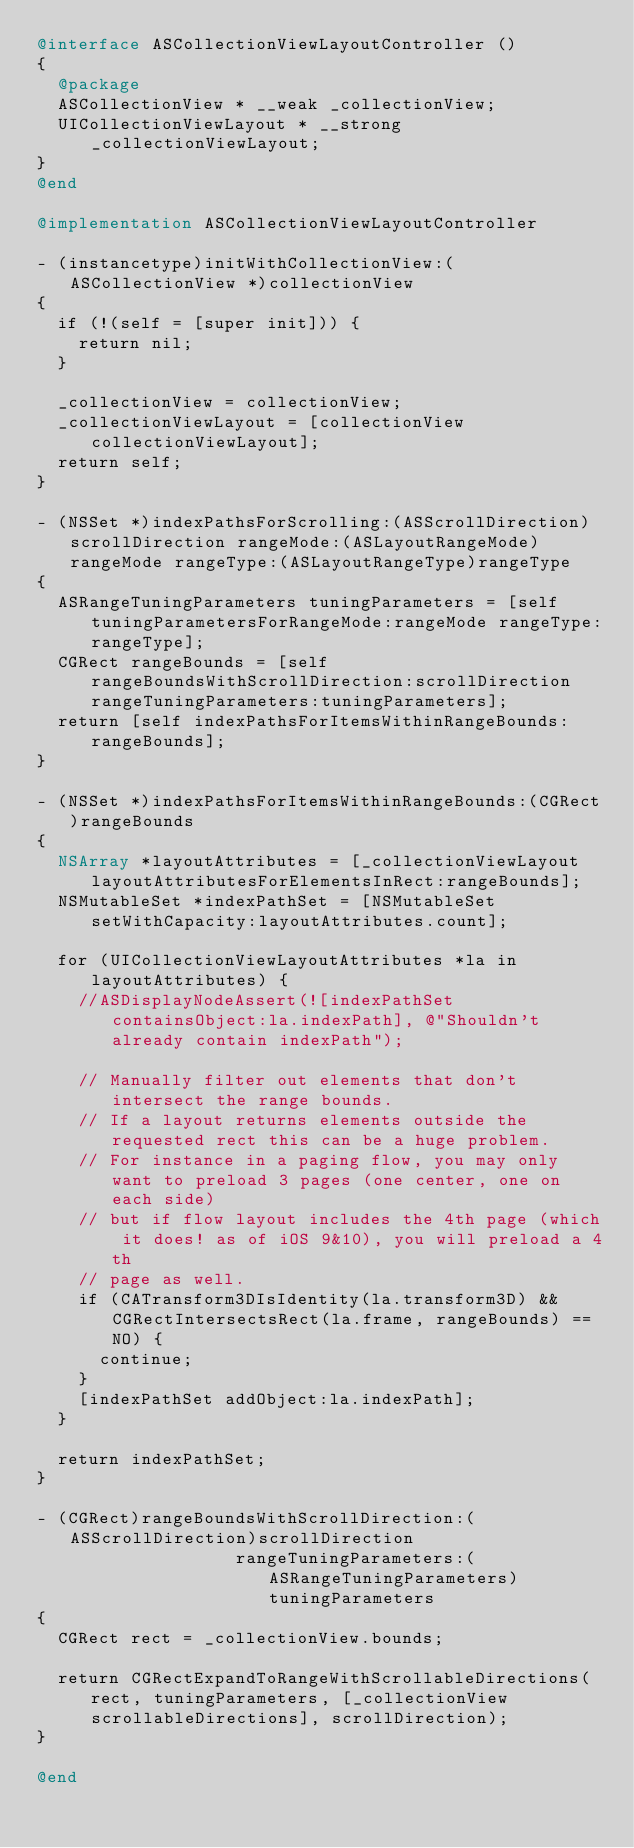Convert code to text. <code><loc_0><loc_0><loc_500><loc_500><_ObjectiveC_>@interface ASCollectionViewLayoutController ()
{
  @package
  ASCollectionView * __weak _collectionView;
  UICollectionViewLayout * __strong _collectionViewLayout;
}
@end

@implementation ASCollectionViewLayoutController

- (instancetype)initWithCollectionView:(ASCollectionView *)collectionView
{
  if (!(self = [super init])) {
    return nil;
  }
  
  _collectionView = collectionView;
  _collectionViewLayout = [collectionView collectionViewLayout];
  return self;
}

- (NSSet *)indexPathsForScrolling:(ASScrollDirection)scrollDirection rangeMode:(ASLayoutRangeMode)rangeMode rangeType:(ASLayoutRangeType)rangeType
{
  ASRangeTuningParameters tuningParameters = [self tuningParametersForRangeMode:rangeMode rangeType:rangeType];
  CGRect rangeBounds = [self rangeBoundsWithScrollDirection:scrollDirection rangeTuningParameters:tuningParameters];
  return [self indexPathsForItemsWithinRangeBounds:rangeBounds];
}

- (NSSet *)indexPathsForItemsWithinRangeBounds:(CGRect)rangeBounds
{
  NSArray *layoutAttributes = [_collectionViewLayout layoutAttributesForElementsInRect:rangeBounds];
  NSMutableSet *indexPathSet = [NSMutableSet setWithCapacity:layoutAttributes.count];
  
  for (UICollectionViewLayoutAttributes *la in layoutAttributes) {
    //ASDisplayNodeAssert(![indexPathSet containsObject:la.indexPath], @"Shouldn't already contain indexPath");

    // Manually filter out elements that don't intersect the range bounds.
    // If a layout returns elements outside the requested rect this can be a huge problem.
    // For instance in a paging flow, you may only want to preload 3 pages (one center, one on each side)
    // but if flow layout includes the 4th page (which it does! as of iOS 9&10), you will preload a 4th
    // page as well.
    if (CATransform3DIsIdentity(la.transform3D) && CGRectIntersectsRect(la.frame, rangeBounds) == NO) {
      continue;
    }
    [indexPathSet addObject:la.indexPath];
  }

  return indexPathSet;
}

- (CGRect)rangeBoundsWithScrollDirection:(ASScrollDirection)scrollDirection
                   rangeTuningParameters:(ASRangeTuningParameters)tuningParameters
{
  CGRect rect = _collectionView.bounds;
  
  return CGRectExpandToRangeWithScrollableDirections(rect, tuningParameters, [_collectionView scrollableDirections], scrollDirection);
}

@end
</code> 